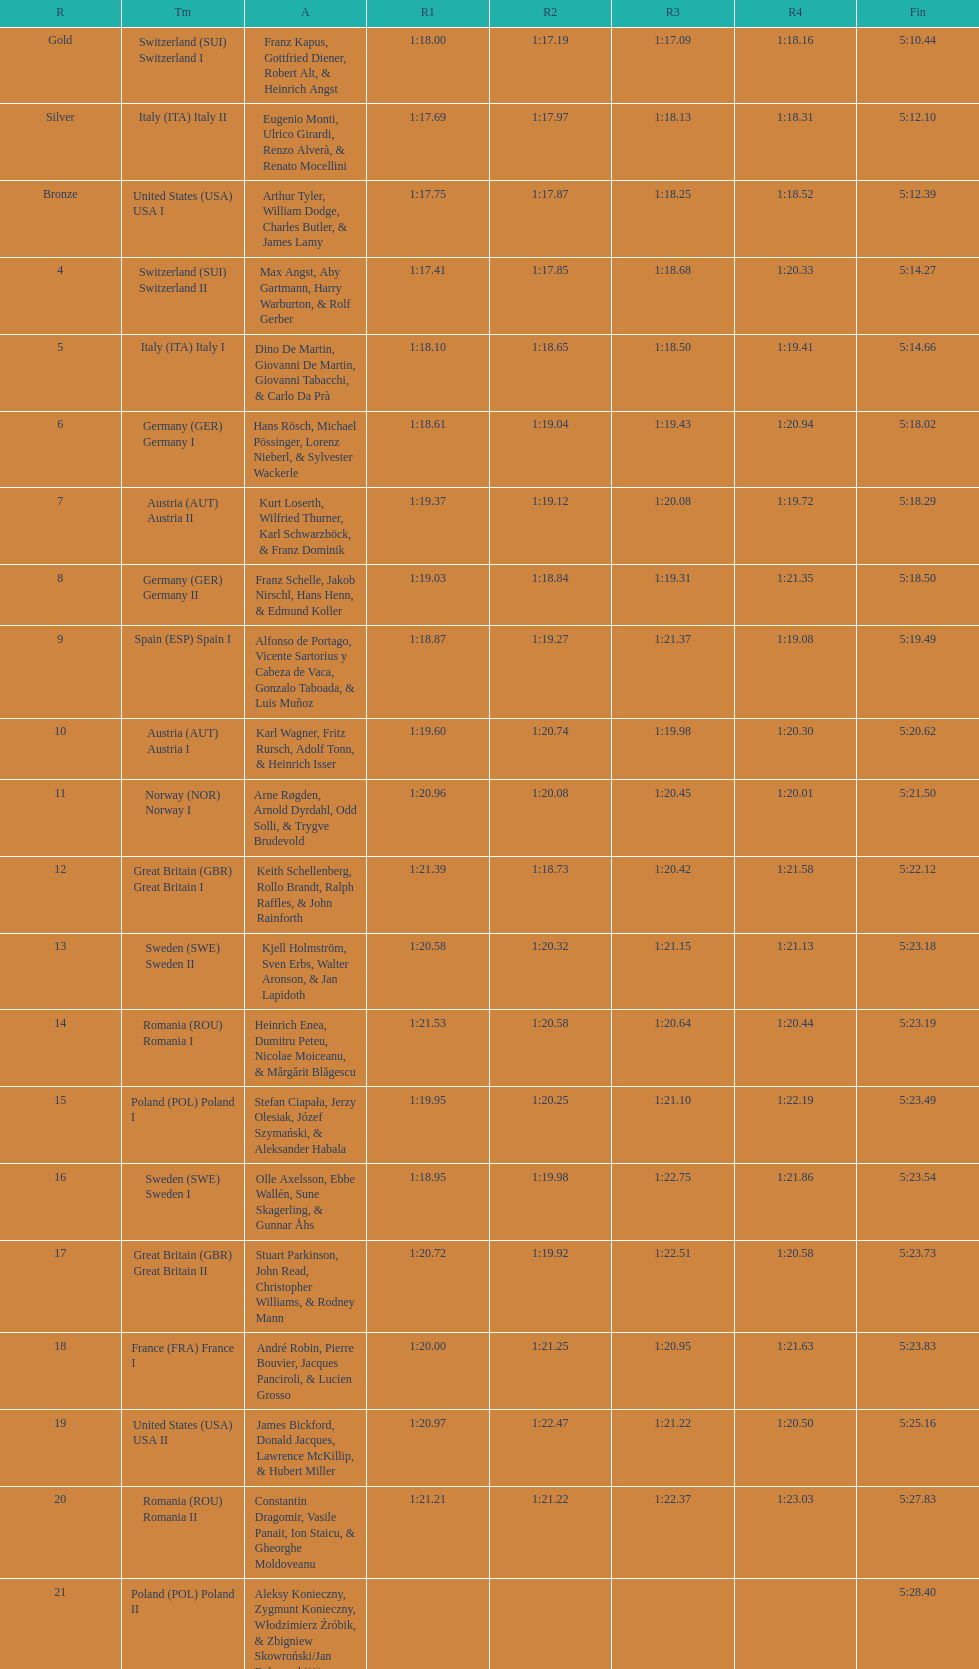How many teams did germany have? 2. 